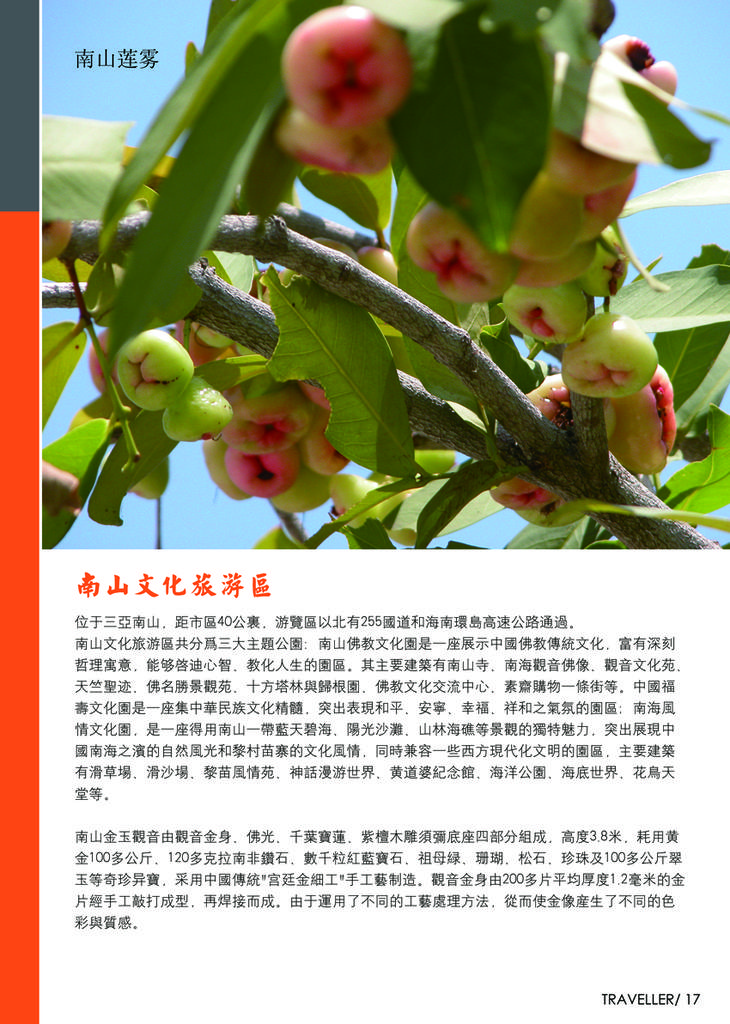What type of image is being described? The image is a poster. What is shown on the poster? There are fruit plants depicted on the poster. Are there any words on the poster? Yes, there is text on the poster. What does the dad say about the fruit plants on the poster? There is no dad present in the image, and therefore no comment can be attributed to him. 